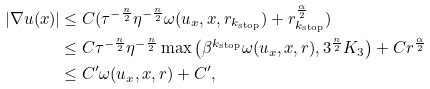<formula> <loc_0><loc_0><loc_500><loc_500>| \nabla u ( x ) | & \leq C ( \tau ^ { - \frac { n } { 2 } } \eta ^ { - \frac { n } { 2 } } \omega ( u _ { x } , x , r _ { k _ { \text {stop} } } ) + r _ { k _ { \text {stop} } } ^ { \frac { \alpha } { 2 } } ) \\ & \leq C \tau ^ { - \frac { n } { 2 } } \eta ^ { - \frac { n } { 2 } } \max \left ( \beta ^ { k _ { \text {stop} } } \omega ( u _ { x } , x , r ) , 3 ^ { \frac { n } { 2 } } K _ { 3 } \right ) + C r ^ { \frac { \alpha } { 2 } } \\ & \leq C ^ { \prime } \omega ( u _ { x } , x , r ) + C ^ { \prime } ,</formula> 